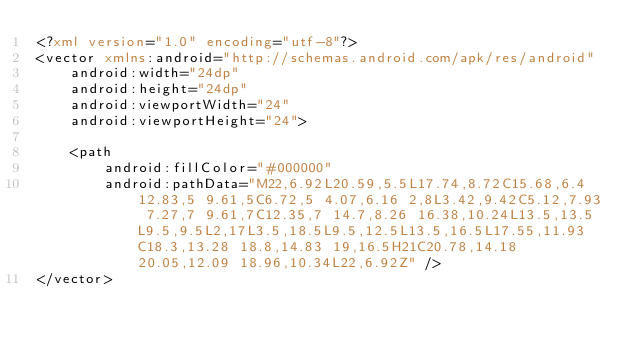Convert code to text. <code><loc_0><loc_0><loc_500><loc_500><_XML_><?xml version="1.0" encoding="utf-8"?>
<vector xmlns:android="http://schemas.android.com/apk/res/android"
    android:width="24dp"
    android:height="24dp"
    android:viewportWidth="24"
    android:viewportHeight="24">

    <path
        android:fillColor="#000000"
        android:pathData="M22,6.92L20.59,5.5L17.74,8.72C15.68,6.4 12.83,5 9.61,5C6.72,5 4.07,6.16 2,8L3.42,9.42C5.12,7.93 7.27,7 9.61,7C12.35,7 14.7,8.26 16.38,10.24L13.5,13.5L9.5,9.5L2,17L3.5,18.5L9.5,12.5L13.5,16.5L17.55,11.93C18.3,13.28 18.8,14.83 19,16.5H21C20.78,14.18 20.05,12.09 18.96,10.34L22,6.92Z" />
</vector></code> 